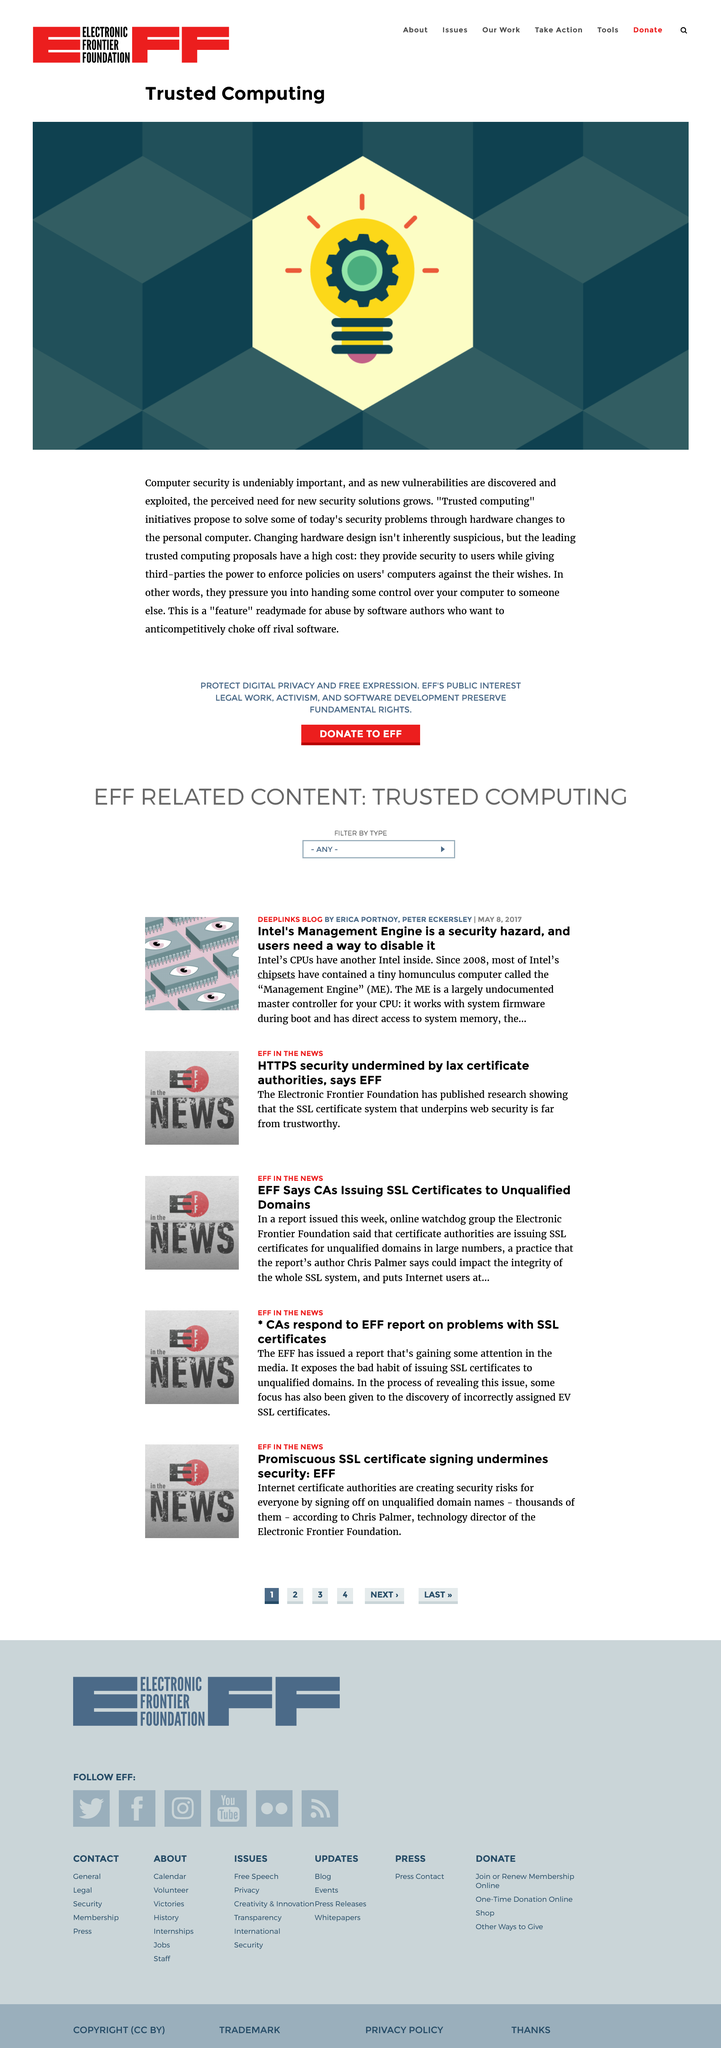List a handful of essential elements in this visual. The color of the light bulb is yellow. The title of this page is "Trusted Computing. This page pertains to trusted computing initiatives. 